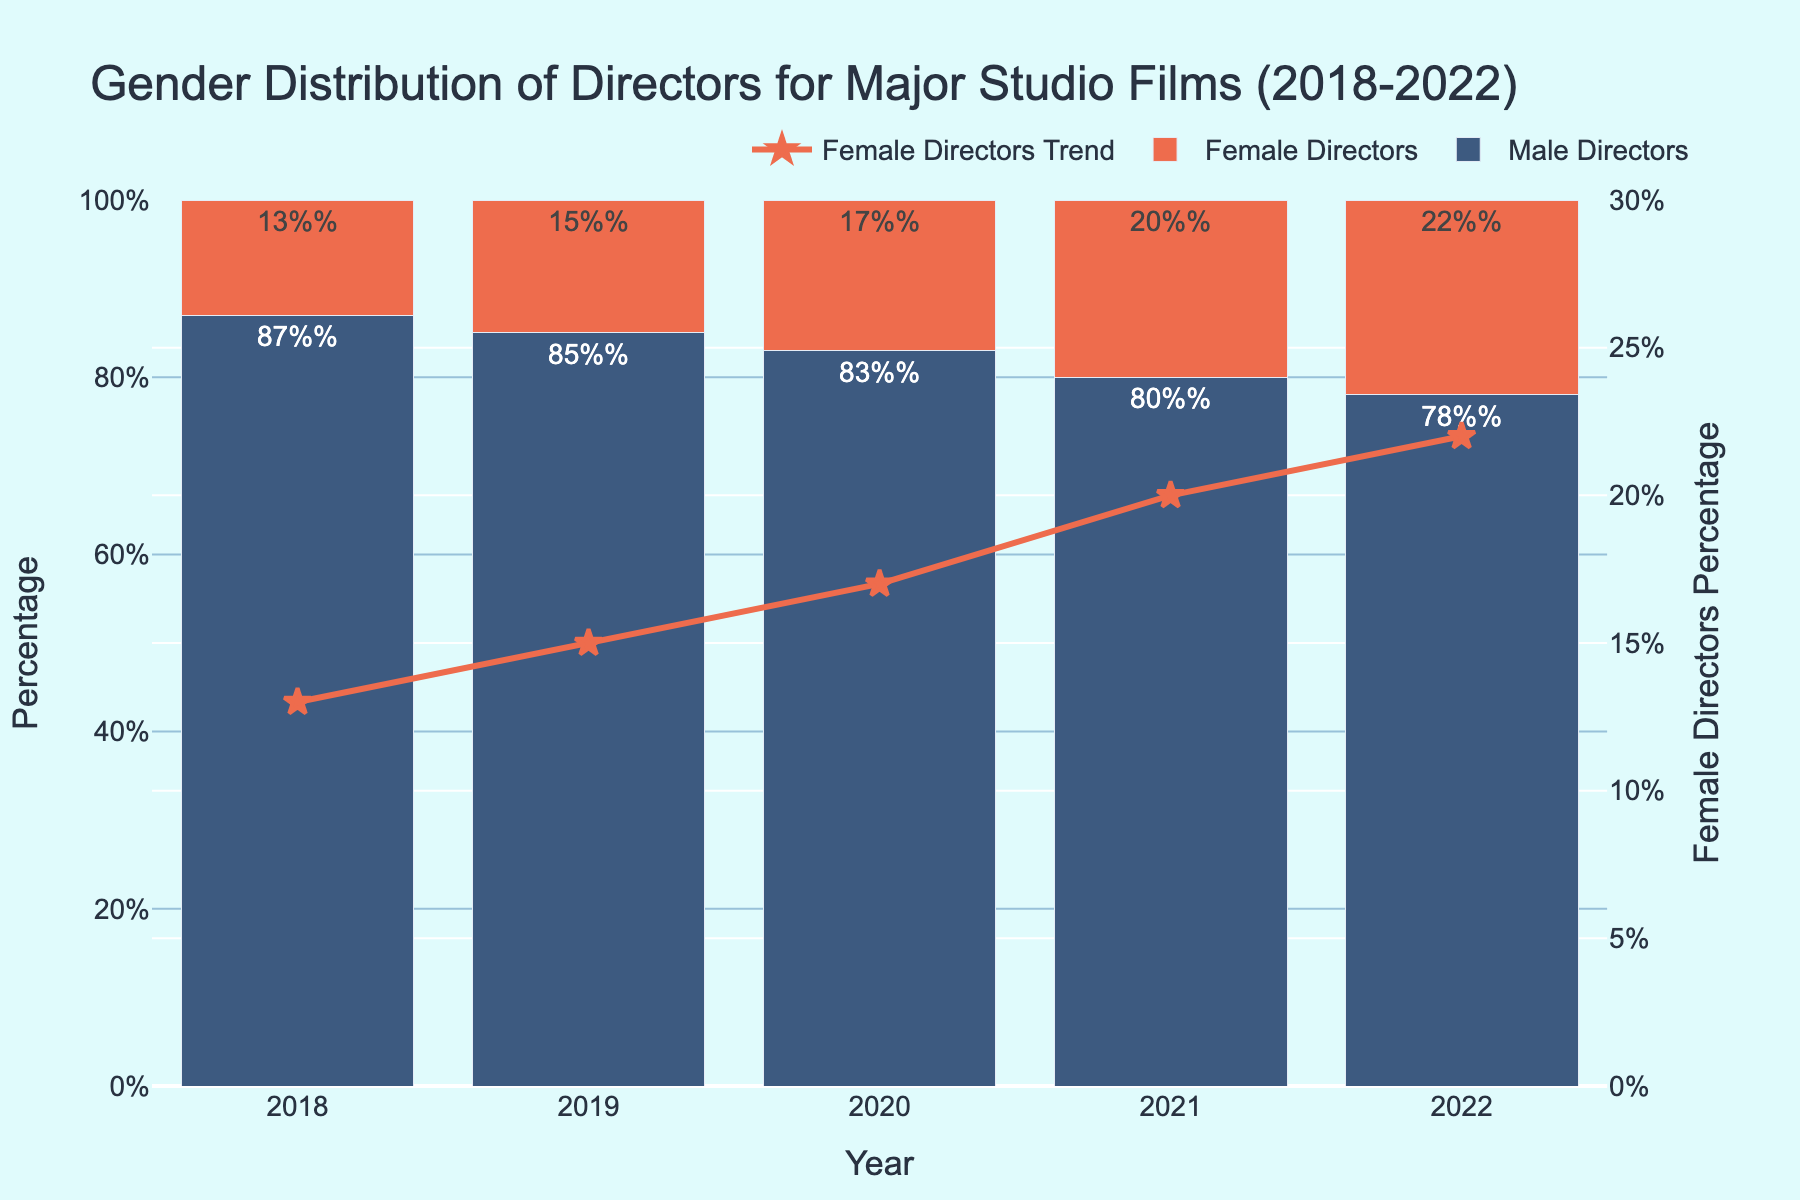What is the percentage of female directors in 2020? Look for the bar that represents the year 2020 and check the label or height of the red bar, which indicates the percentage of female directors.
Answer: 17% In which year was the gap between male and female directors the smallest? Find the year where the difference between the blue and red bars is the smallest. Compute the difference for each year and identify the smallest one.
Answer: 2022 Which year shows the highest percentage of female directors, and what is that percentage? Identify the tallest red bar in the chart and note the corresponding year and the percentage shown by that red bar.
Answer: 2022, 22% How much did the percentage of female directors increase from 2018 to 2022? Subtract the percentage of female directors in 2018 from that in 2022.
Answer: 9% Compare the percentage of female directors between 2019 and 2021. Which year had a higher percentage and by how much? Check the heights of the red bars for 2019 and 2021. Subtract the smaller percentage from the larger one to find the difference and note which year is higher.
Answer: 2021, by 5% What is the combined percentage of male and female directors in 2020? For the year 2020, add the percentage of male directors and female directors together.
Answer: 100% How does the trend of female directors' percentage change over the years, based on the line graph? Observe the red line connecting the markers; it shows an increasing trend from 2018 to 2022.
Answer: Increasing趋势 In which year did male directors see the most significant decrease in their percentage, compared to the previous year? Look at the blue bars and identify the year where the drop between consecutive years is the largest.
Answer: 2021 What are the color codes used to represent male and female directors on the chart? Observe the colors of the bars for male and female directors and state their colors.
Answer: Blue for male, red for female 